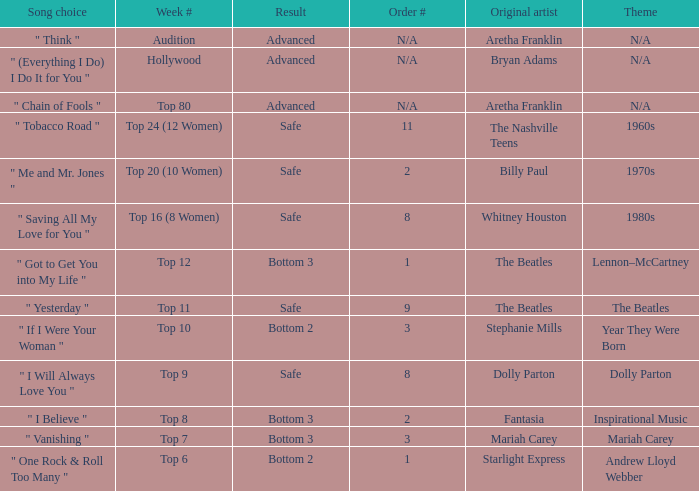Name the song choice when week number is hollywood " (Everything I Do) I Do It for You ". 